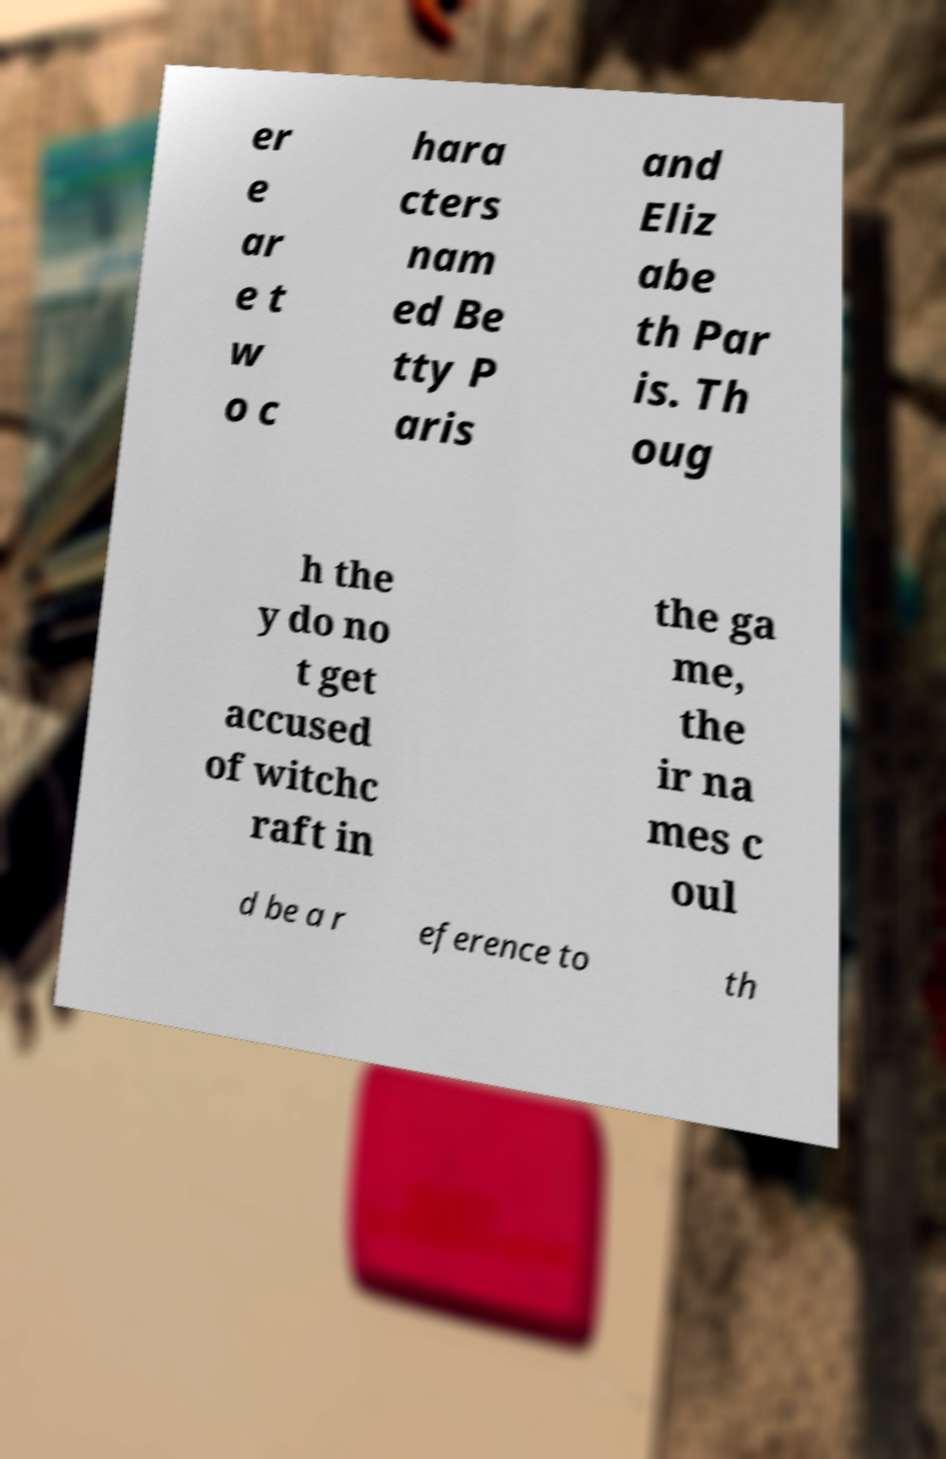There's text embedded in this image that I need extracted. Can you transcribe it verbatim? er e ar e t w o c hara cters nam ed Be tty P aris and Eliz abe th Par is. Th oug h the y do no t get accused of witchc raft in the ga me, the ir na mes c oul d be a r eference to th 